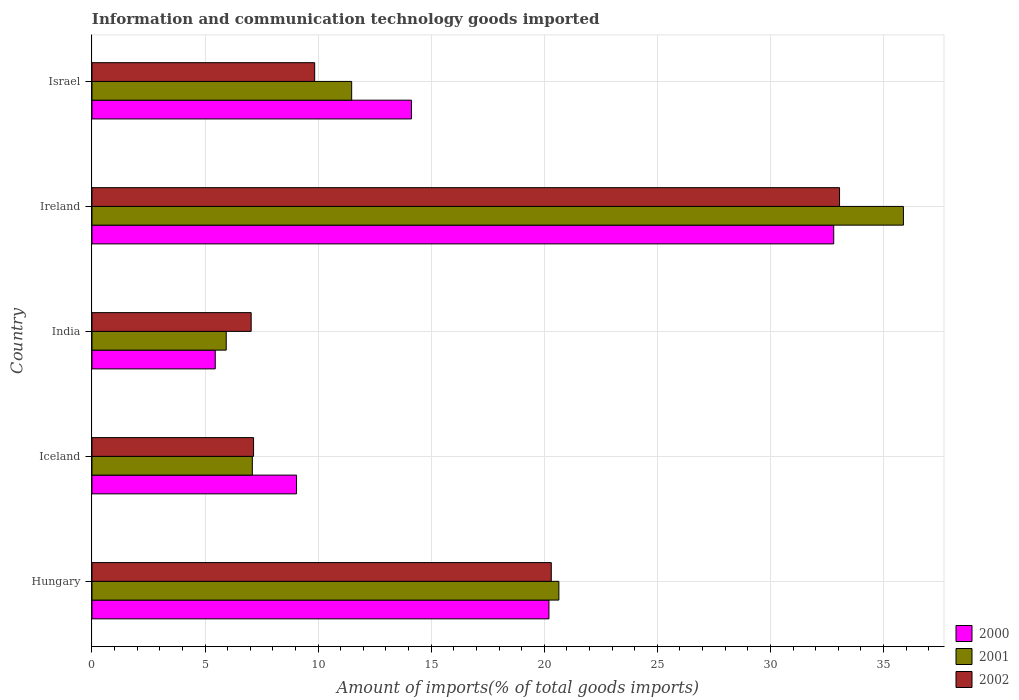How many groups of bars are there?
Offer a terse response. 5. Are the number of bars per tick equal to the number of legend labels?
Give a very brief answer. Yes. Are the number of bars on each tick of the Y-axis equal?
Make the answer very short. Yes. How many bars are there on the 2nd tick from the bottom?
Keep it short and to the point. 3. In how many cases, is the number of bars for a given country not equal to the number of legend labels?
Ensure brevity in your answer.  0. What is the amount of goods imported in 2002 in Israel?
Your answer should be compact. 9.85. Across all countries, what is the maximum amount of goods imported in 2001?
Your answer should be compact. 35.88. Across all countries, what is the minimum amount of goods imported in 2001?
Make the answer very short. 5.94. In which country was the amount of goods imported in 2001 maximum?
Your answer should be compact. Ireland. What is the total amount of goods imported in 2000 in the graph?
Your response must be concise. 81.63. What is the difference between the amount of goods imported in 2002 in India and that in Ireland?
Provide a succinct answer. -26.02. What is the difference between the amount of goods imported in 2000 in Israel and the amount of goods imported in 2002 in Ireland?
Offer a very short reply. -18.93. What is the average amount of goods imported in 2002 per country?
Your response must be concise. 15.48. What is the difference between the amount of goods imported in 2002 and amount of goods imported in 2001 in Iceland?
Give a very brief answer. 0.05. In how many countries, is the amount of goods imported in 2002 greater than 5 %?
Provide a succinct answer. 5. What is the ratio of the amount of goods imported in 2002 in Iceland to that in Ireland?
Offer a terse response. 0.22. Is the amount of goods imported in 2000 in Hungary less than that in India?
Your response must be concise. No. What is the difference between the highest and the second highest amount of goods imported in 2001?
Provide a short and direct response. 15.24. What is the difference between the highest and the lowest amount of goods imported in 2002?
Offer a very short reply. 26.02. Is the sum of the amount of goods imported in 2002 in India and Ireland greater than the maximum amount of goods imported in 2000 across all countries?
Provide a succinct answer. Yes. Is it the case that in every country, the sum of the amount of goods imported in 2000 and amount of goods imported in 2001 is greater than the amount of goods imported in 2002?
Make the answer very short. Yes. How many bars are there?
Your response must be concise. 15. Does the graph contain grids?
Your answer should be very brief. Yes. What is the title of the graph?
Make the answer very short. Information and communication technology goods imported. What is the label or title of the X-axis?
Keep it short and to the point. Amount of imports(% of total goods imports). What is the Amount of imports(% of total goods imports) in 2000 in Hungary?
Make the answer very short. 20.21. What is the Amount of imports(% of total goods imports) of 2001 in Hungary?
Your response must be concise. 20.65. What is the Amount of imports(% of total goods imports) in 2002 in Hungary?
Ensure brevity in your answer.  20.31. What is the Amount of imports(% of total goods imports) in 2000 in Iceland?
Your answer should be very brief. 9.05. What is the Amount of imports(% of total goods imports) of 2001 in Iceland?
Your answer should be very brief. 7.09. What is the Amount of imports(% of total goods imports) of 2002 in Iceland?
Your response must be concise. 7.14. What is the Amount of imports(% of total goods imports) in 2000 in India?
Keep it short and to the point. 5.45. What is the Amount of imports(% of total goods imports) in 2001 in India?
Provide a short and direct response. 5.94. What is the Amount of imports(% of total goods imports) in 2002 in India?
Provide a short and direct response. 7.04. What is the Amount of imports(% of total goods imports) in 2000 in Ireland?
Offer a very short reply. 32.8. What is the Amount of imports(% of total goods imports) in 2001 in Ireland?
Make the answer very short. 35.88. What is the Amount of imports(% of total goods imports) of 2002 in Ireland?
Provide a short and direct response. 33.06. What is the Amount of imports(% of total goods imports) in 2000 in Israel?
Your answer should be very brief. 14.13. What is the Amount of imports(% of total goods imports) of 2001 in Israel?
Your answer should be very brief. 11.48. What is the Amount of imports(% of total goods imports) in 2002 in Israel?
Give a very brief answer. 9.85. Across all countries, what is the maximum Amount of imports(% of total goods imports) in 2000?
Provide a short and direct response. 32.8. Across all countries, what is the maximum Amount of imports(% of total goods imports) of 2001?
Your answer should be very brief. 35.88. Across all countries, what is the maximum Amount of imports(% of total goods imports) in 2002?
Your response must be concise. 33.06. Across all countries, what is the minimum Amount of imports(% of total goods imports) of 2000?
Your answer should be compact. 5.45. Across all countries, what is the minimum Amount of imports(% of total goods imports) of 2001?
Make the answer very short. 5.94. Across all countries, what is the minimum Amount of imports(% of total goods imports) of 2002?
Your response must be concise. 7.04. What is the total Amount of imports(% of total goods imports) in 2000 in the graph?
Your response must be concise. 81.63. What is the total Amount of imports(% of total goods imports) of 2001 in the graph?
Provide a short and direct response. 81.04. What is the total Amount of imports(% of total goods imports) in 2002 in the graph?
Ensure brevity in your answer.  77.4. What is the difference between the Amount of imports(% of total goods imports) of 2000 in Hungary and that in Iceland?
Offer a terse response. 11.16. What is the difference between the Amount of imports(% of total goods imports) in 2001 in Hungary and that in Iceland?
Make the answer very short. 13.56. What is the difference between the Amount of imports(% of total goods imports) of 2002 in Hungary and that in Iceland?
Offer a terse response. 13.17. What is the difference between the Amount of imports(% of total goods imports) of 2000 in Hungary and that in India?
Offer a terse response. 14.76. What is the difference between the Amount of imports(% of total goods imports) of 2001 in Hungary and that in India?
Ensure brevity in your answer.  14.71. What is the difference between the Amount of imports(% of total goods imports) of 2002 in Hungary and that in India?
Ensure brevity in your answer.  13.27. What is the difference between the Amount of imports(% of total goods imports) of 2000 in Hungary and that in Ireland?
Give a very brief answer. -12.59. What is the difference between the Amount of imports(% of total goods imports) of 2001 in Hungary and that in Ireland?
Offer a terse response. -15.24. What is the difference between the Amount of imports(% of total goods imports) in 2002 in Hungary and that in Ireland?
Offer a terse response. -12.75. What is the difference between the Amount of imports(% of total goods imports) in 2000 in Hungary and that in Israel?
Offer a very short reply. 6.08. What is the difference between the Amount of imports(% of total goods imports) in 2001 in Hungary and that in Israel?
Your answer should be very brief. 9.16. What is the difference between the Amount of imports(% of total goods imports) in 2002 in Hungary and that in Israel?
Give a very brief answer. 10.46. What is the difference between the Amount of imports(% of total goods imports) in 2000 in Iceland and that in India?
Give a very brief answer. 3.59. What is the difference between the Amount of imports(% of total goods imports) of 2001 in Iceland and that in India?
Provide a short and direct response. 1.15. What is the difference between the Amount of imports(% of total goods imports) in 2002 in Iceland and that in India?
Provide a short and direct response. 0.11. What is the difference between the Amount of imports(% of total goods imports) of 2000 in Iceland and that in Ireland?
Provide a short and direct response. -23.75. What is the difference between the Amount of imports(% of total goods imports) in 2001 in Iceland and that in Ireland?
Provide a succinct answer. -28.79. What is the difference between the Amount of imports(% of total goods imports) of 2002 in Iceland and that in Ireland?
Provide a succinct answer. -25.91. What is the difference between the Amount of imports(% of total goods imports) of 2000 in Iceland and that in Israel?
Provide a short and direct response. -5.08. What is the difference between the Amount of imports(% of total goods imports) in 2001 in Iceland and that in Israel?
Make the answer very short. -4.39. What is the difference between the Amount of imports(% of total goods imports) in 2002 in Iceland and that in Israel?
Ensure brevity in your answer.  -2.7. What is the difference between the Amount of imports(% of total goods imports) in 2000 in India and that in Ireland?
Your answer should be compact. -27.35. What is the difference between the Amount of imports(% of total goods imports) of 2001 in India and that in Ireland?
Give a very brief answer. -29.94. What is the difference between the Amount of imports(% of total goods imports) in 2002 in India and that in Ireland?
Offer a very short reply. -26.02. What is the difference between the Amount of imports(% of total goods imports) in 2000 in India and that in Israel?
Your response must be concise. -8.68. What is the difference between the Amount of imports(% of total goods imports) in 2001 in India and that in Israel?
Your answer should be compact. -5.55. What is the difference between the Amount of imports(% of total goods imports) of 2002 in India and that in Israel?
Offer a very short reply. -2.81. What is the difference between the Amount of imports(% of total goods imports) in 2000 in Ireland and that in Israel?
Your answer should be compact. 18.67. What is the difference between the Amount of imports(% of total goods imports) in 2001 in Ireland and that in Israel?
Your answer should be compact. 24.4. What is the difference between the Amount of imports(% of total goods imports) in 2002 in Ireland and that in Israel?
Provide a short and direct response. 23.21. What is the difference between the Amount of imports(% of total goods imports) of 2000 in Hungary and the Amount of imports(% of total goods imports) of 2001 in Iceland?
Offer a terse response. 13.12. What is the difference between the Amount of imports(% of total goods imports) in 2000 in Hungary and the Amount of imports(% of total goods imports) in 2002 in Iceland?
Ensure brevity in your answer.  13.06. What is the difference between the Amount of imports(% of total goods imports) of 2001 in Hungary and the Amount of imports(% of total goods imports) of 2002 in Iceland?
Make the answer very short. 13.5. What is the difference between the Amount of imports(% of total goods imports) in 2000 in Hungary and the Amount of imports(% of total goods imports) in 2001 in India?
Your response must be concise. 14.27. What is the difference between the Amount of imports(% of total goods imports) of 2000 in Hungary and the Amount of imports(% of total goods imports) of 2002 in India?
Offer a very short reply. 13.17. What is the difference between the Amount of imports(% of total goods imports) of 2001 in Hungary and the Amount of imports(% of total goods imports) of 2002 in India?
Your answer should be compact. 13.61. What is the difference between the Amount of imports(% of total goods imports) in 2000 in Hungary and the Amount of imports(% of total goods imports) in 2001 in Ireland?
Keep it short and to the point. -15.67. What is the difference between the Amount of imports(% of total goods imports) of 2000 in Hungary and the Amount of imports(% of total goods imports) of 2002 in Ireland?
Keep it short and to the point. -12.85. What is the difference between the Amount of imports(% of total goods imports) of 2001 in Hungary and the Amount of imports(% of total goods imports) of 2002 in Ireland?
Your response must be concise. -12.41. What is the difference between the Amount of imports(% of total goods imports) of 2000 in Hungary and the Amount of imports(% of total goods imports) of 2001 in Israel?
Provide a short and direct response. 8.72. What is the difference between the Amount of imports(% of total goods imports) of 2000 in Hungary and the Amount of imports(% of total goods imports) of 2002 in Israel?
Ensure brevity in your answer.  10.36. What is the difference between the Amount of imports(% of total goods imports) in 2001 in Hungary and the Amount of imports(% of total goods imports) in 2002 in Israel?
Give a very brief answer. 10.8. What is the difference between the Amount of imports(% of total goods imports) of 2000 in Iceland and the Amount of imports(% of total goods imports) of 2001 in India?
Offer a terse response. 3.11. What is the difference between the Amount of imports(% of total goods imports) in 2000 in Iceland and the Amount of imports(% of total goods imports) in 2002 in India?
Offer a terse response. 2.01. What is the difference between the Amount of imports(% of total goods imports) in 2001 in Iceland and the Amount of imports(% of total goods imports) in 2002 in India?
Offer a very short reply. 0.05. What is the difference between the Amount of imports(% of total goods imports) of 2000 in Iceland and the Amount of imports(% of total goods imports) of 2001 in Ireland?
Your answer should be compact. -26.84. What is the difference between the Amount of imports(% of total goods imports) in 2000 in Iceland and the Amount of imports(% of total goods imports) in 2002 in Ireland?
Offer a very short reply. -24.01. What is the difference between the Amount of imports(% of total goods imports) in 2001 in Iceland and the Amount of imports(% of total goods imports) in 2002 in Ireland?
Give a very brief answer. -25.97. What is the difference between the Amount of imports(% of total goods imports) in 2000 in Iceland and the Amount of imports(% of total goods imports) in 2001 in Israel?
Give a very brief answer. -2.44. What is the difference between the Amount of imports(% of total goods imports) in 2000 in Iceland and the Amount of imports(% of total goods imports) in 2002 in Israel?
Make the answer very short. -0.8. What is the difference between the Amount of imports(% of total goods imports) in 2001 in Iceland and the Amount of imports(% of total goods imports) in 2002 in Israel?
Keep it short and to the point. -2.76. What is the difference between the Amount of imports(% of total goods imports) of 2000 in India and the Amount of imports(% of total goods imports) of 2001 in Ireland?
Your response must be concise. -30.43. What is the difference between the Amount of imports(% of total goods imports) in 2000 in India and the Amount of imports(% of total goods imports) in 2002 in Ireland?
Provide a succinct answer. -27.61. What is the difference between the Amount of imports(% of total goods imports) in 2001 in India and the Amount of imports(% of total goods imports) in 2002 in Ireland?
Provide a succinct answer. -27.12. What is the difference between the Amount of imports(% of total goods imports) in 2000 in India and the Amount of imports(% of total goods imports) in 2001 in Israel?
Provide a short and direct response. -6.03. What is the difference between the Amount of imports(% of total goods imports) in 2000 in India and the Amount of imports(% of total goods imports) in 2002 in Israel?
Keep it short and to the point. -4.4. What is the difference between the Amount of imports(% of total goods imports) of 2001 in India and the Amount of imports(% of total goods imports) of 2002 in Israel?
Make the answer very short. -3.91. What is the difference between the Amount of imports(% of total goods imports) in 2000 in Ireland and the Amount of imports(% of total goods imports) in 2001 in Israel?
Ensure brevity in your answer.  21.32. What is the difference between the Amount of imports(% of total goods imports) in 2000 in Ireland and the Amount of imports(% of total goods imports) in 2002 in Israel?
Give a very brief answer. 22.95. What is the difference between the Amount of imports(% of total goods imports) in 2001 in Ireland and the Amount of imports(% of total goods imports) in 2002 in Israel?
Make the answer very short. 26.03. What is the average Amount of imports(% of total goods imports) in 2000 per country?
Give a very brief answer. 16.33. What is the average Amount of imports(% of total goods imports) of 2001 per country?
Offer a very short reply. 16.21. What is the average Amount of imports(% of total goods imports) of 2002 per country?
Make the answer very short. 15.48. What is the difference between the Amount of imports(% of total goods imports) of 2000 and Amount of imports(% of total goods imports) of 2001 in Hungary?
Make the answer very short. -0.44. What is the difference between the Amount of imports(% of total goods imports) in 2000 and Amount of imports(% of total goods imports) in 2002 in Hungary?
Offer a terse response. -0.1. What is the difference between the Amount of imports(% of total goods imports) in 2001 and Amount of imports(% of total goods imports) in 2002 in Hungary?
Ensure brevity in your answer.  0.34. What is the difference between the Amount of imports(% of total goods imports) in 2000 and Amount of imports(% of total goods imports) in 2001 in Iceland?
Ensure brevity in your answer.  1.96. What is the difference between the Amount of imports(% of total goods imports) of 2000 and Amount of imports(% of total goods imports) of 2002 in Iceland?
Your response must be concise. 1.9. What is the difference between the Amount of imports(% of total goods imports) of 2001 and Amount of imports(% of total goods imports) of 2002 in Iceland?
Provide a succinct answer. -0.05. What is the difference between the Amount of imports(% of total goods imports) of 2000 and Amount of imports(% of total goods imports) of 2001 in India?
Make the answer very short. -0.49. What is the difference between the Amount of imports(% of total goods imports) of 2000 and Amount of imports(% of total goods imports) of 2002 in India?
Offer a terse response. -1.59. What is the difference between the Amount of imports(% of total goods imports) of 2001 and Amount of imports(% of total goods imports) of 2002 in India?
Offer a terse response. -1.1. What is the difference between the Amount of imports(% of total goods imports) of 2000 and Amount of imports(% of total goods imports) of 2001 in Ireland?
Offer a very short reply. -3.08. What is the difference between the Amount of imports(% of total goods imports) in 2000 and Amount of imports(% of total goods imports) in 2002 in Ireland?
Make the answer very short. -0.26. What is the difference between the Amount of imports(% of total goods imports) of 2001 and Amount of imports(% of total goods imports) of 2002 in Ireland?
Make the answer very short. 2.82. What is the difference between the Amount of imports(% of total goods imports) in 2000 and Amount of imports(% of total goods imports) in 2001 in Israel?
Provide a short and direct response. 2.64. What is the difference between the Amount of imports(% of total goods imports) in 2000 and Amount of imports(% of total goods imports) in 2002 in Israel?
Give a very brief answer. 4.28. What is the difference between the Amount of imports(% of total goods imports) in 2001 and Amount of imports(% of total goods imports) in 2002 in Israel?
Offer a terse response. 1.64. What is the ratio of the Amount of imports(% of total goods imports) of 2000 in Hungary to that in Iceland?
Make the answer very short. 2.23. What is the ratio of the Amount of imports(% of total goods imports) in 2001 in Hungary to that in Iceland?
Your answer should be compact. 2.91. What is the ratio of the Amount of imports(% of total goods imports) of 2002 in Hungary to that in Iceland?
Offer a terse response. 2.84. What is the ratio of the Amount of imports(% of total goods imports) of 2000 in Hungary to that in India?
Make the answer very short. 3.71. What is the ratio of the Amount of imports(% of total goods imports) of 2001 in Hungary to that in India?
Your response must be concise. 3.48. What is the ratio of the Amount of imports(% of total goods imports) of 2002 in Hungary to that in India?
Ensure brevity in your answer.  2.89. What is the ratio of the Amount of imports(% of total goods imports) of 2000 in Hungary to that in Ireland?
Your answer should be very brief. 0.62. What is the ratio of the Amount of imports(% of total goods imports) in 2001 in Hungary to that in Ireland?
Keep it short and to the point. 0.58. What is the ratio of the Amount of imports(% of total goods imports) of 2002 in Hungary to that in Ireland?
Ensure brevity in your answer.  0.61. What is the ratio of the Amount of imports(% of total goods imports) in 2000 in Hungary to that in Israel?
Keep it short and to the point. 1.43. What is the ratio of the Amount of imports(% of total goods imports) of 2001 in Hungary to that in Israel?
Offer a very short reply. 1.8. What is the ratio of the Amount of imports(% of total goods imports) of 2002 in Hungary to that in Israel?
Offer a very short reply. 2.06. What is the ratio of the Amount of imports(% of total goods imports) in 2000 in Iceland to that in India?
Offer a very short reply. 1.66. What is the ratio of the Amount of imports(% of total goods imports) in 2001 in Iceland to that in India?
Offer a terse response. 1.19. What is the ratio of the Amount of imports(% of total goods imports) of 2000 in Iceland to that in Ireland?
Keep it short and to the point. 0.28. What is the ratio of the Amount of imports(% of total goods imports) of 2001 in Iceland to that in Ireland?
Your answer should be compact. 0.2. What is the ratio of the Amount of imports(% of total goods imports) in 2002 in Iceland to that in Ireland?
Ensure brevity in your answer.  0.22. What is the ratio of the Amount of imports(% of total goods imports) of 2000 in Iceland to that in Israel?
Ensure brevity in your answer.  0.64. What is the ratio of the Amount of imports(% of total goods imports) of 2001 in Iceland to that in Israel?
Keep it short and to the point. 0.62. What is the ratio of the Amount of imports(% of total goods imports) of 2002 in Iceland to that in Israel?
Give a very brief answer. 0.73. What is the ratio of the Amount of imports(% of total goods imports) of 2000 in India to that in Ireland?
Give a very brief answer. 0.17. What is the ratio of the Amount of imports(% of total goods imports) of 2001 in India to that in Ireland?
Offer a terse response. 0.17. What is the ratio of the Amount of imports(% of total goods imports) in 2002 in India to that in Ireland?
Offer a terse response. 0.21. What is the ratio of the Amount of imports(% of total goods imports) of 2000 in India to that in Israel?
Your answer should be very brief. 0.39. What is the ratio of the Amount of imports(% of total goods imports) of 2001 in India to that in Israel?
Ensure brevity in your answer.  0.52. What is the ratio of the Amount of imports(% of total goods imports) of 2002 in India to that in Israel?
Ensure brevity in your answer.  0.71. What is the ratio of the Amount of imports(% of total goods imports) of 2000 in Ireland to that in Israel?
Offer a terse response. 2.32. What is the ratio of the Amount of imports(% of total goods imports) in 2001 in Ireland to that in Israel?
Your response must be concise. 3.12. What is the ratio of the Amount of imports(% of total goods imports) of 2002 in Ireland to that in Israel?
Provide a short and direct response. 3.36. What is the difference between the highest and the second highest Amount of imports(% of total goods imports) in 2000?
Your answer should be compact. 12.59. What is the difference between the highest and the second highest Amount of imports(% of total goods imports) of 2001?
Provide a succinct answer. 15.24. What is the difference between the highest and the second highest Amount of imports(% of total goods imports) of 2002?
Offer a very short reply. 12.75. What is the difference between the highest and the lowest Amount of imports(% of total goods imports) in 2000?
Your response must be concise. 27.35. What is the difference between the highest and the lowest Amount of imports(% of total goods imports) in 2001?
Make the answer very short. 29.94. What is the difference between the highest and the lowest Amount of imports(% of total goods imports) of 2002?
Your answer should be compact. 26.02. 